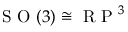Convert formula to latex. <formula><loc_0><loc_0><loc_500><loc_500>S O ( 3 ) \cong R P ^ { 3 }</formula> 